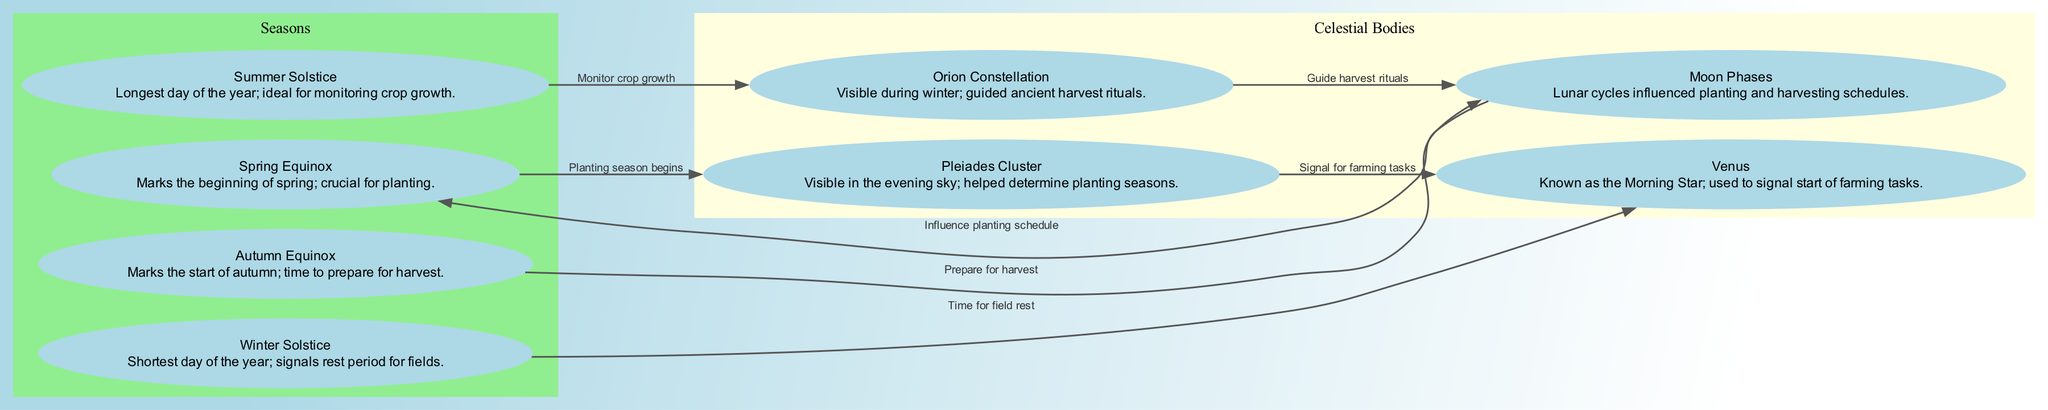What marks the beginning of spring? The "Spring Equinox" is indicated in the diagram as the point that marks the beginning of spring and is crucial for planting.
Answer: Spring Equinox How many celestial bodies are represented in the diagram? The diagram includes four celestial bodies: the Pleiades Cluster, Orion Constellation, Venus, and Moon Phases, which are all categorized in the celestial bodies section.
Answer: 4 What is the relationship between the Summer Solstice and the Orion Constellation? The diagram shows an edge from the Summer Solstice to the Orion Constellation, labeled "Monitor crop growth," indicating that during summer, farmers looked to Orion to keep an eye on how their crops were faring.
Answer: Monitor crop growth During which event do farmers prepare for harvest? According to the diagram, farmers prepare for harvest during the Autumn Equinox, which is indicated as the event that marks the start of autumn.
Answer: Autumn Equinox What does the Venus indicate in the diagram? The "Venus" node in the diagram is connected to the Winter Solstice, indicating that it signifies a time for field rest, suggesting farmers reduced activity during this period.
Answer: Time for field rest How does the Moon Phases influence planting schedules? The diagram shows that the Moon Phases node has an edge leading to the Spring Equinox, indicating that lunar cycles influenced the timing of planting which occurs at spring.
Answer: Influence planting schedule What assists farmers in determining planting seasons according to the diagram? The "Pleiades Cluster" is connected to the Spring Equinox in the diagram, indicating that its visibility in the evening sky helped ancient farmers determine when to start planting.
Answer: Pleiades Cluster What ritual is guided by Orion in the winter? The diagram links Orion Constellation to the Moon Phases with an edge labeled "Guide harvest rituals," demonstrating that Orion helped guide harvest-related activities among ancient farmers in winter.
Answer: Guide harvest rituals What significant change occurs during the Winter Solstice? The Winter Solstice node is connected to Venus, and its description indicates that it marks the shortest day of the year, signaling a rest period for fields, which is a significant change in the agricultural cycle.
Answer: Shortest day of the year 